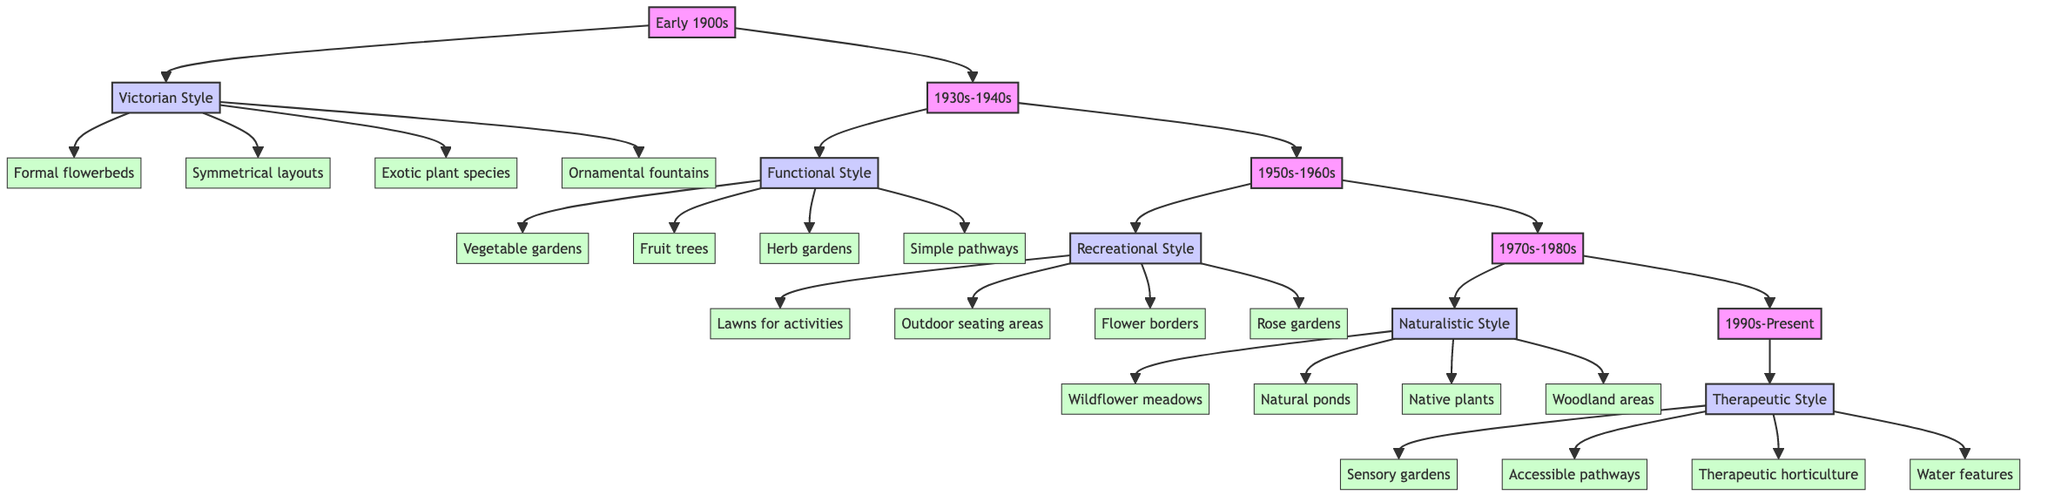What garden style is represented in the early 1900s? The diagram shows that the garden style during the early 1900s is "Victorian." This is directly noted as one of the periods and its associated style in the flow chart.
Answer: Victorian How many features are listed under the Functional style? By examining the Functional style node, there are four features branching out from it: vegetable gardens, fruit trees, herb gardens, and simple pathways. Thus, the answer is obtained by counting these features.
Answer: 4 What period does the Naturalistic style belong to? The diagram indicates that the Naturalistic style is associated with the period "1970s-1980s." This relationship is visually represented in the flow from the period node to the style node above it.
Answer: 1970s-1980s Which style focuses on healing and wellness? The diagram identifies "Therapeutic" as the style that emphasizes healing and wellness. This information is positioned at the highest level of the flow chart, making it easily visible.
Answer: Therapeutic What is the main influence of the Victorian style? The influence of the Victorian style is described in the diagram as "European garden design principles." This can be found directly below the style in the flow.
Answer: European garden design principles Which style has features related to outdoor seating? The "Recreational" style includes several features that relate to outdoor socialization, specifically "outdoor seating areas." This feature directly branches out from that style node.
Answer: Recreational How many main styles of gardens are covered in the diagram? There are five distinct styles outlined in the diagram corresponding to their time periods, which can be counted from the main style nodes connected to each period node.
Answer: 5 What gardening tasks are associated with the Therapeutic style? The tasks listed under the Therapeutic style can be counted: sensory plant cultivation, pathway maintenance, and interactive gardening activities, resulting in three tasks. This can be directly derived from the tasks node connected to the Therapeutic style.
Answer: 3 What is a common feature of the Naturalistic garden style? The diagram highlights "wildflower meadows" as one of the common features of the Naturalistic style, which can be directly accessed from the flow chart representation.
Answer: Wildflower meadows 